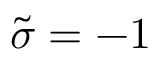Convert formula to latex. <formula><loc_0><loc_0><loc_500><loc_500>\tilde { \sigma } = - 1</formula> 